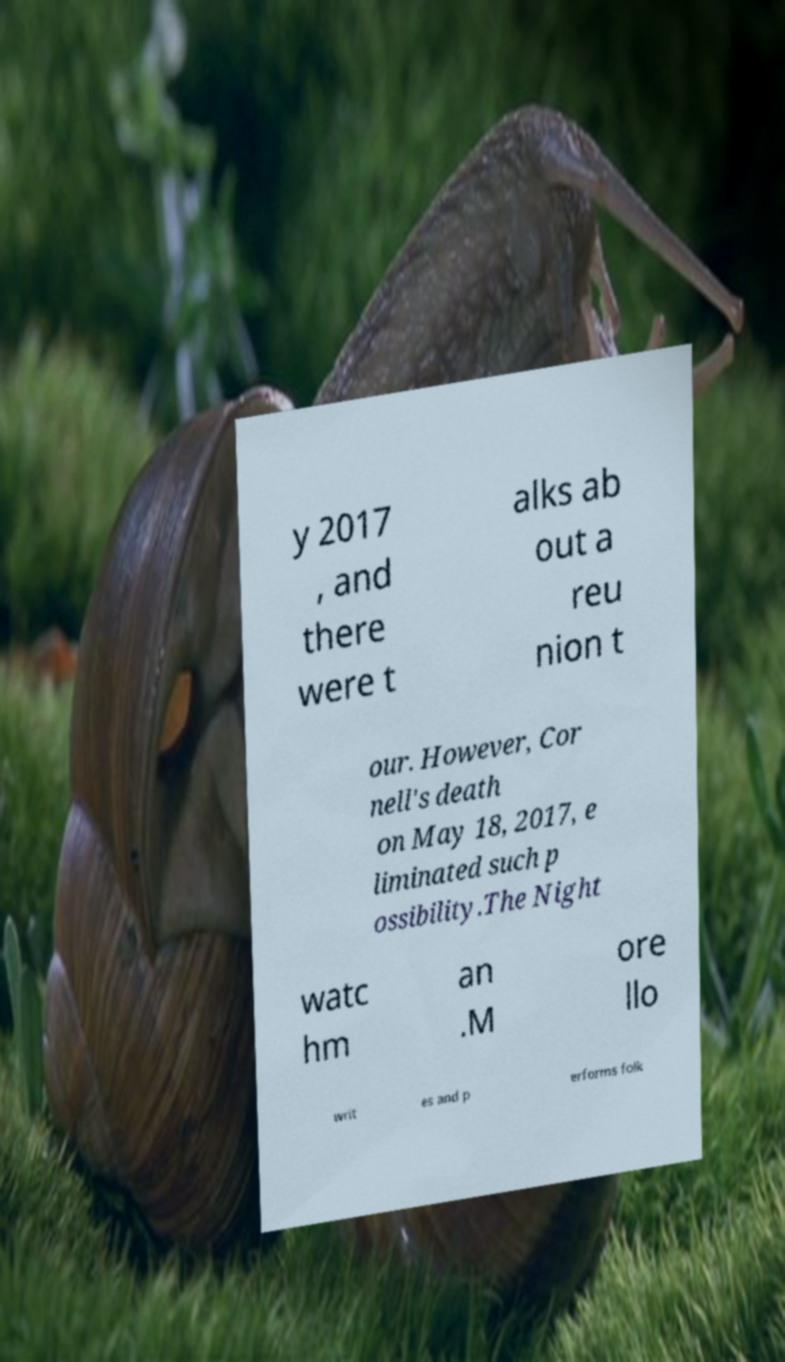Can you read and provide the text displayed in the image?This photo seems to have some interesting text. Can you extract and type it out for me? y 2017 , and there were t alks ab out a reu nion t our. However, Cor nell's death on May 18, 2017, e liminated such p ossibility.The Night watc hm an .M ore llo writ es and p erforms folk 